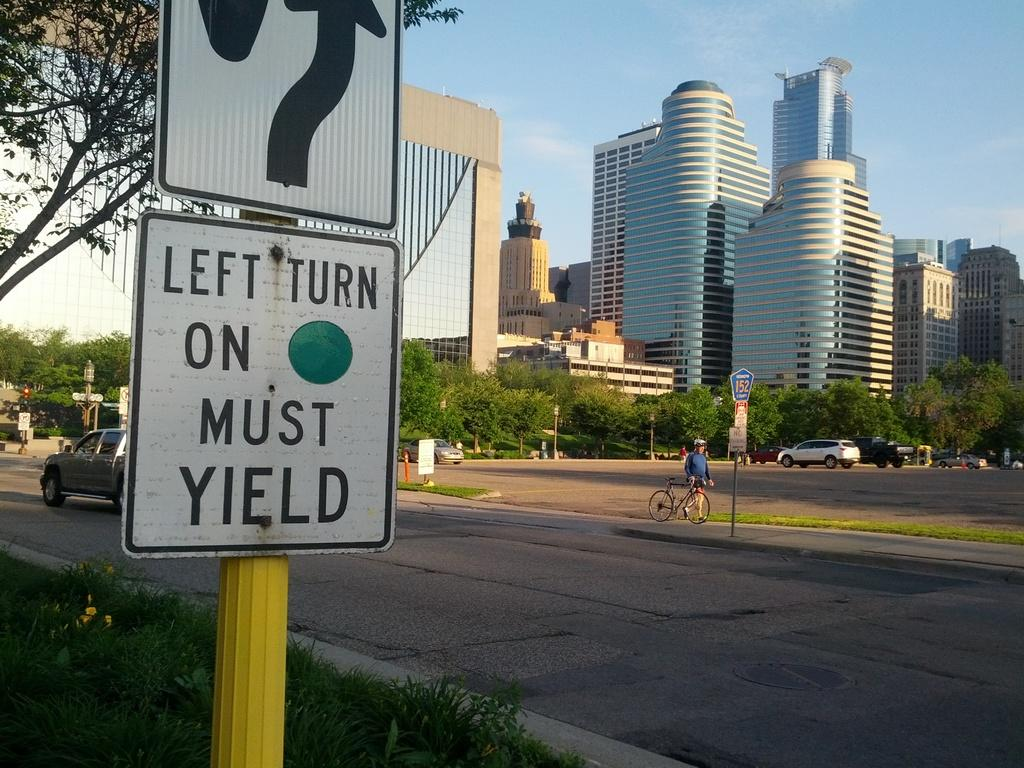<image>
Write a terse but informative summary of the picture. A street sign says left turn on green must yield. 